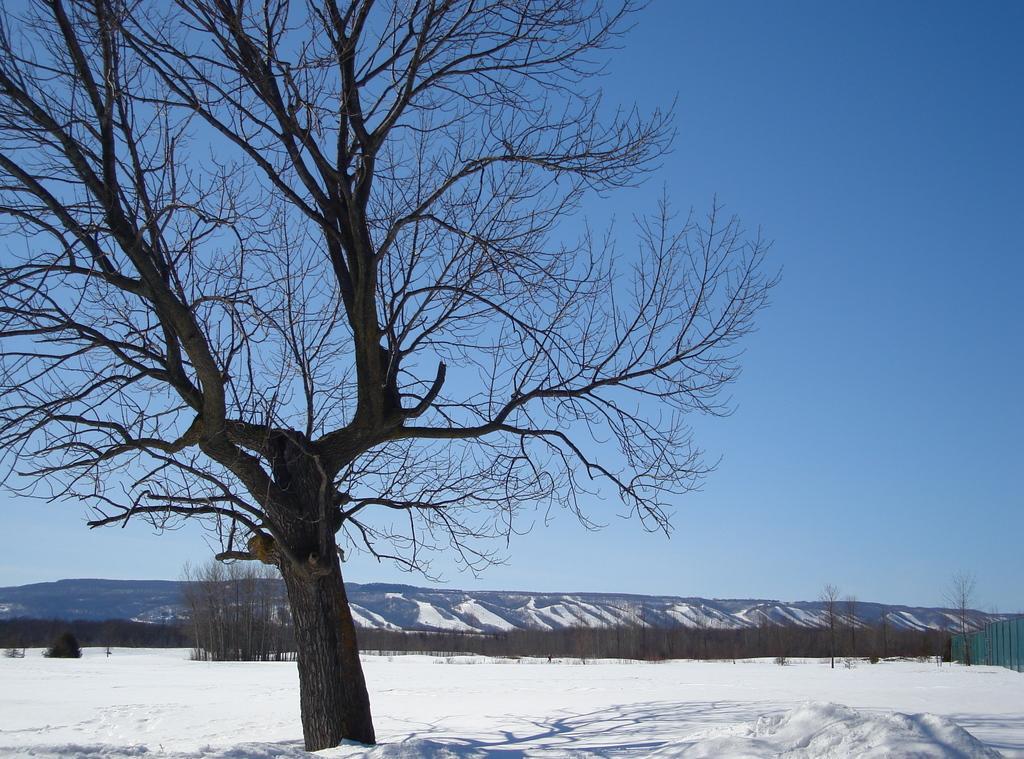How would you summarize this image in a sentence or two? On the left side it is a tree, at the bottom it is the snow, at the top it is the sky. 